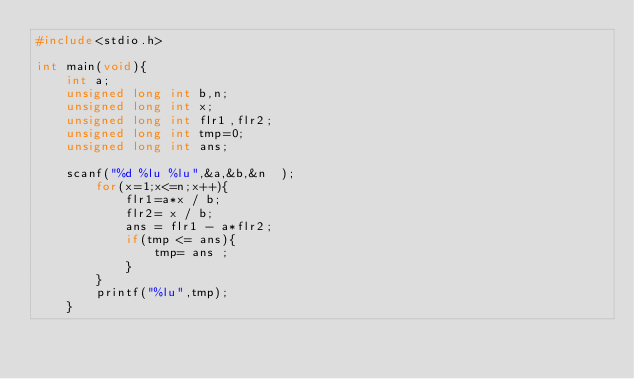<code> <loc_0><loc_0><loc_500><loc_500><_C_>#include<stdio.h>

int main(void){
    int a;
	unsigned long int b,n;
	unsigned long int x;
	unsigned long int flr1,flr2;
    unsigned long int tmp=0;
    unsigned long int ans;
	
    scanf("%d %lu %lu",&a,&b,&n  );
		for(x=1;x<=n;x++){
			flr1=a*x / b;
			flr2= x / b;
			ans = flr1 - a*flr2;
			if(tmp <= ans){
				tmp= ans ;
			}
		}
		printf("%lu",tmp);
	}</code> 